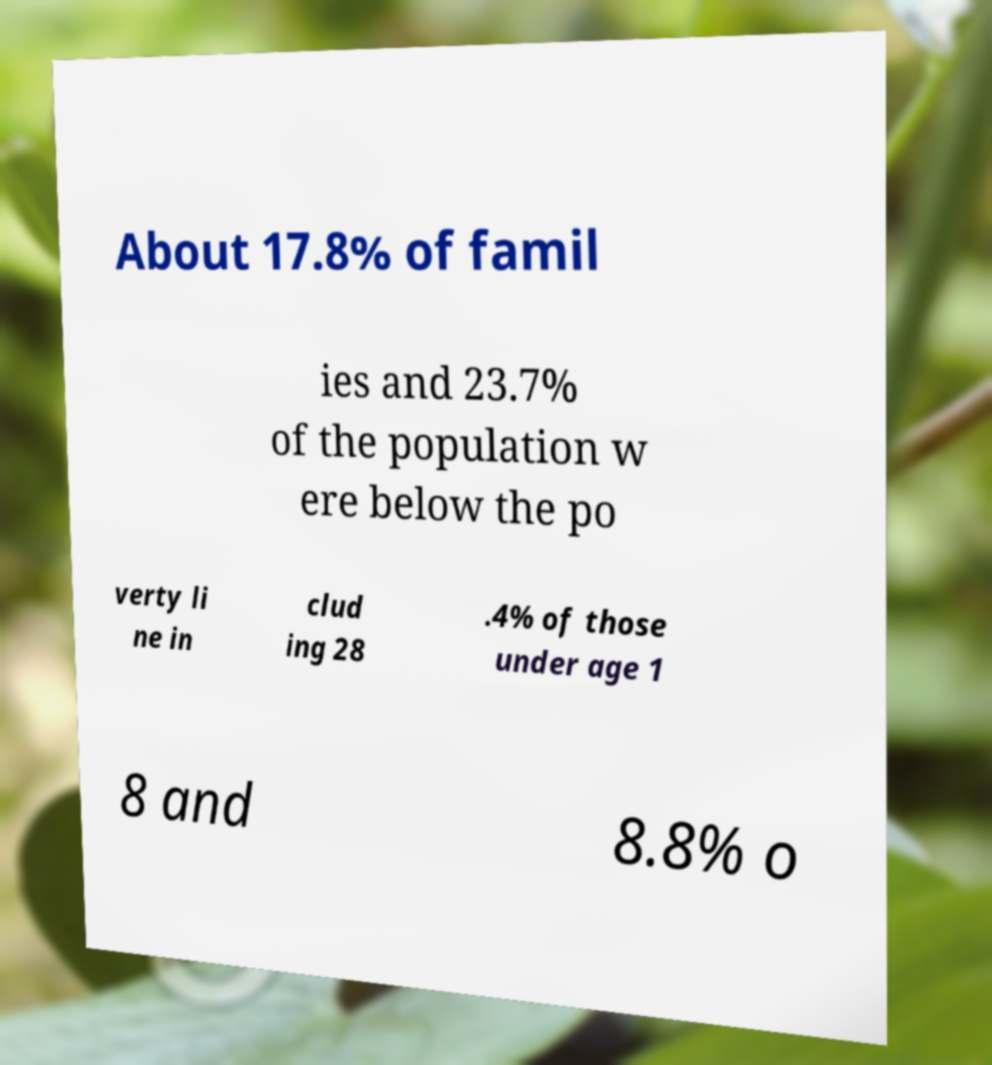What messages or text are displayed in this image? I need them in a readable, typed format. About 17.8% of famil ies and 23.7% of the population w ere below the po verty li ne in clud ing 28 .4% of those under age 1 8 and 8.8% o 